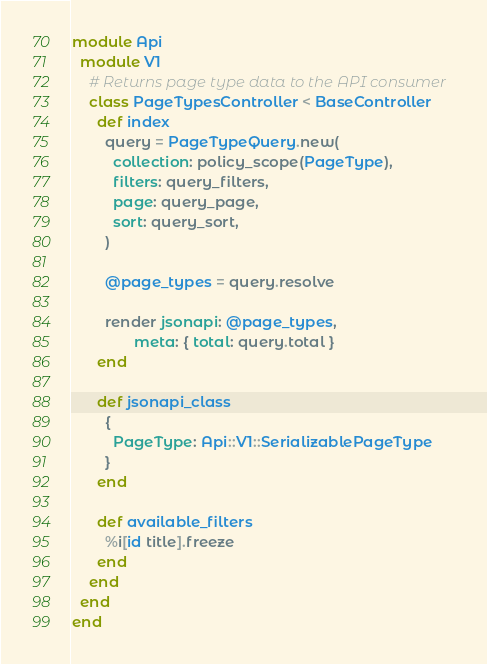<code> <loc_0><loc_0><loc_500><loc_500><_Ruby_>
module Api
  module V1
    # Returns page type data to the API consumer
    class PageTypesController < BaseController
      def index
        query = PageTypeQuery.new(
          collection: policy_scope(PageType),
          filters: query_filters,
          page: query_page,
          sort: query_sort,
        )

        @page_types = query.resolve

        render jsonapi: @page_types,
               meta: { total: query.total }
      end

      def jsonapi_class
        {
          PageType: Api::V1::SerializablePageType
        }
      end

      def available_filters
        %i[id title].freeze
      end
    end
  end
end
</code> 